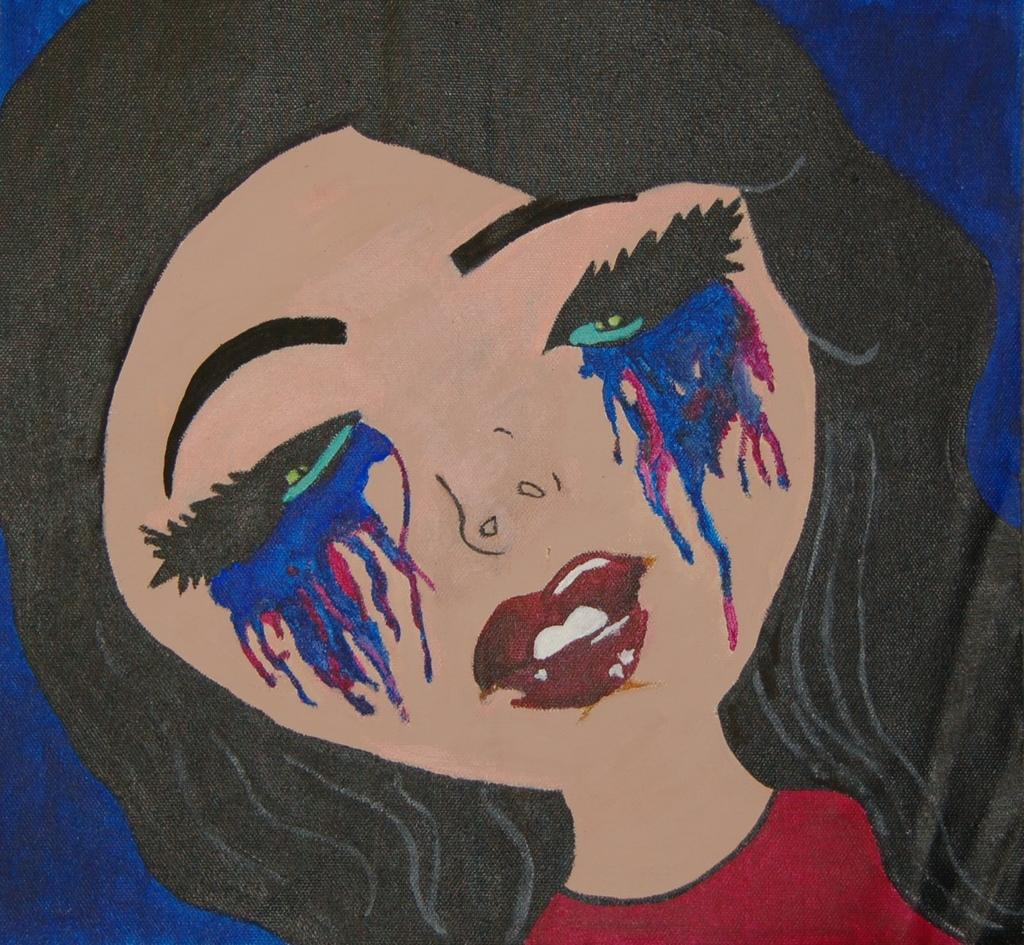What type of artwork is shown in the image? The image is a painting. Who or what is the main subject of the painting? There is a woman depicted in the painting. What is the woman wearing in the painting? The woman is wearing a red dress. What color is the background of the painting? There is a blue background in the painting. How many cakes are displayed on the market stall in the painting? There is no market or cakes present in the painting; it features a woman wearing a red dress against a blue background. 